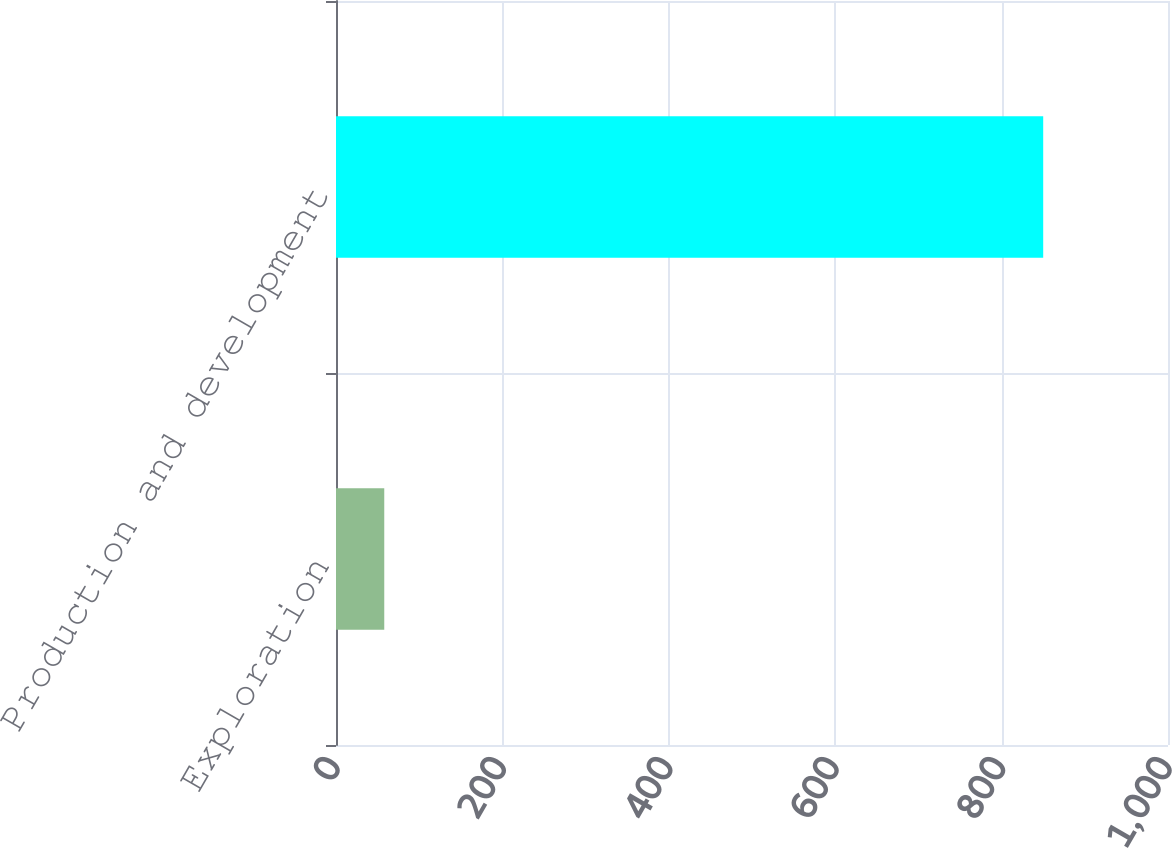Convert chart to OTSL. <chart><loc_0><loc_0><loc_500><loc_500><bar_chart><fcel>Exploration<fcel>Production and development<nl><fcel>58<fcel>850<nl></chart> 